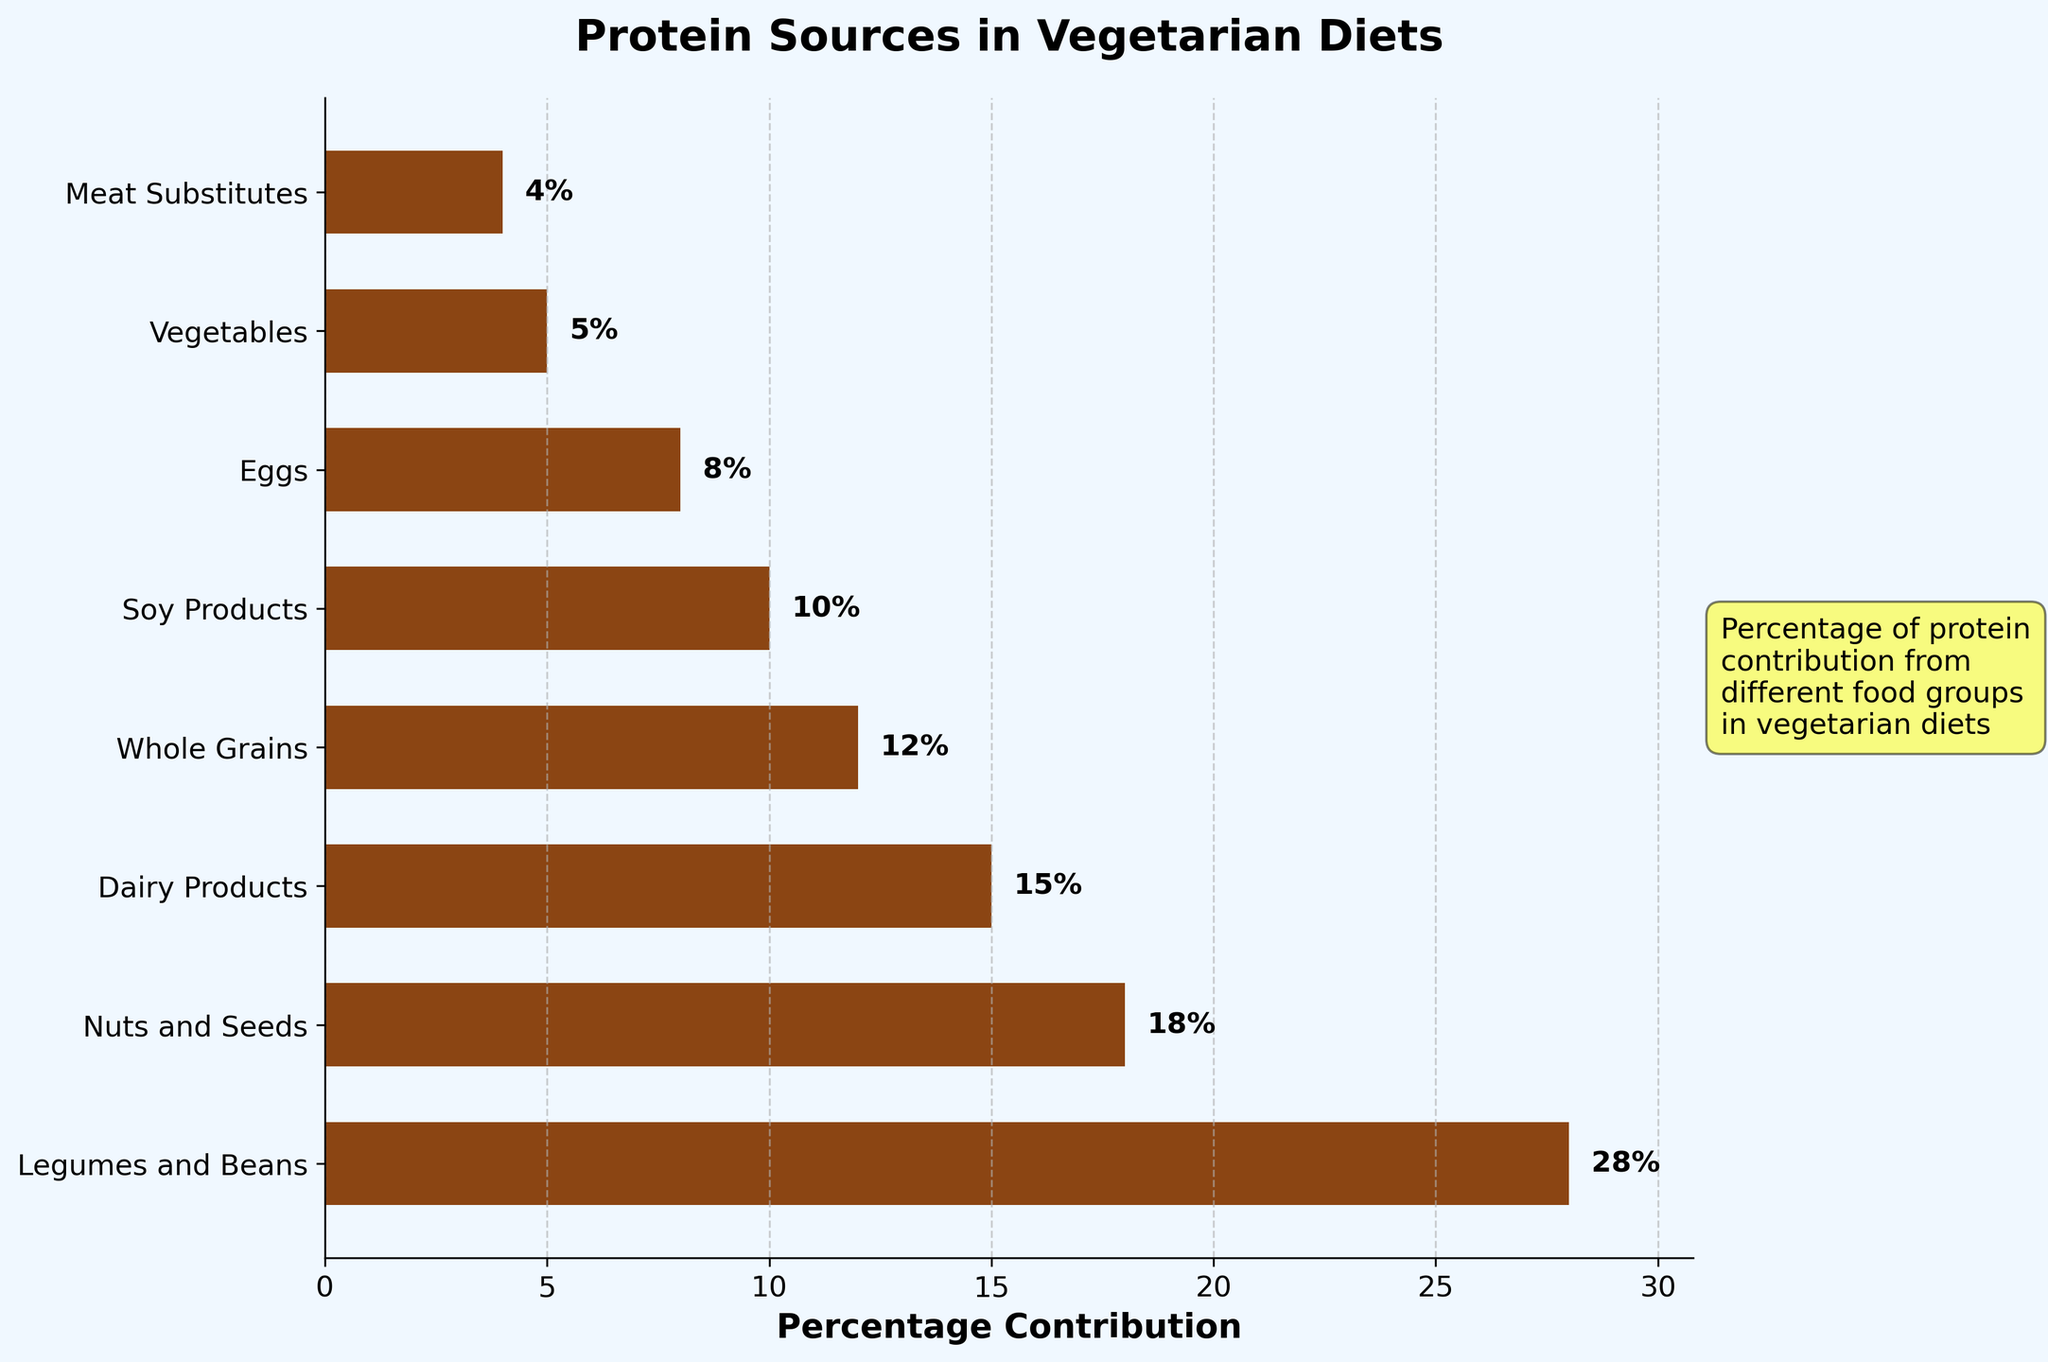What is the food group with the highest percentage contribution to protein in vegetarian diets? The food group that has the longest bar in the chart and the highest percentage label on the top is the one with the highest percentage contribution. In this case, it is "Legumes and Beans" with a contribution of 28%.
Answer: Legumes and Beans Which has a higher percentage contribution to protein, Dairy Products or Soy Products? By observing the lengths of the respective bars and the percentage labels, Dairy Products have a percentage of 15% and Soy Products have a percentage of 10%. Therefore, Dairy Products have a higher contribution.
Answer: Dairy Products What is the combined percentage contribution from Nuts and Seeds and Whole Grains? Adding the percentages of Nuts and Seeds (18%) and Whole Grains (12%) gives the combined contribution. So, 18 + 12 = 30%.
Answer: 30% What is the difference in percentage contribution between Legumes and Beans and Meat Substitutes? Subtract the percentage of Meat Substitutes (4%) from that of Legumes and Beans (28%). So, 28 - 4 = 24%.
Answer: 24% How many food groups contribute more than 10% to protein in vegetarian diets? Count the bars in the chart that have percentage labels higher than 10%. These are Legumes and Beans, Nuts and Seeds, Dairy Products, and Whole Grains, making a total of 4 food groups.
Answer: 4 Which food group contributes the least percentage to protein in vegetarian diets? The shortest bar in the chart with the smallest percentage label indicates the food group with the least contribution. Meat Substitutes have the smallest value of 4%.
Answer: Meat Substitutes Is the percentage contribution of Eggs more or less than half of that of Legumes and Beans? Half of the percentage contribution of Legumes and Beans (28%) is 14%. Comparing this with the percentage of Eggs (8%), Eggs have less than half the contribution of Legumes and Beans.
Answer: Less What is the total percentage contribution from food groups with less than 10% contribution each? Adding the percentages of Soy Products (10%), Eggs (8%), Vegetables (5%), and Meat Substitutes (4%) gives the total contribution. So, 10 + 8 + 5 + 4 = 27%.
Answer: 27% Which food group has a contribution twice that of Vegetables? The contribution of Vegetables is 5%. The food group with double this percentage (which is 10%) is Soy Products, as indicated by the matched percentage label.
Answer: Soy Products Which food groups have a percentage contribution less than that of Dairy Products but more than that of Whole Grains? Comparing the percentages, Dairy Products contribute 15%, and Whole Grains contribute 12%. The food groups with contributions between these values are Nuts and Seeds (18%) and Soy Products (10%).
Answer: None 